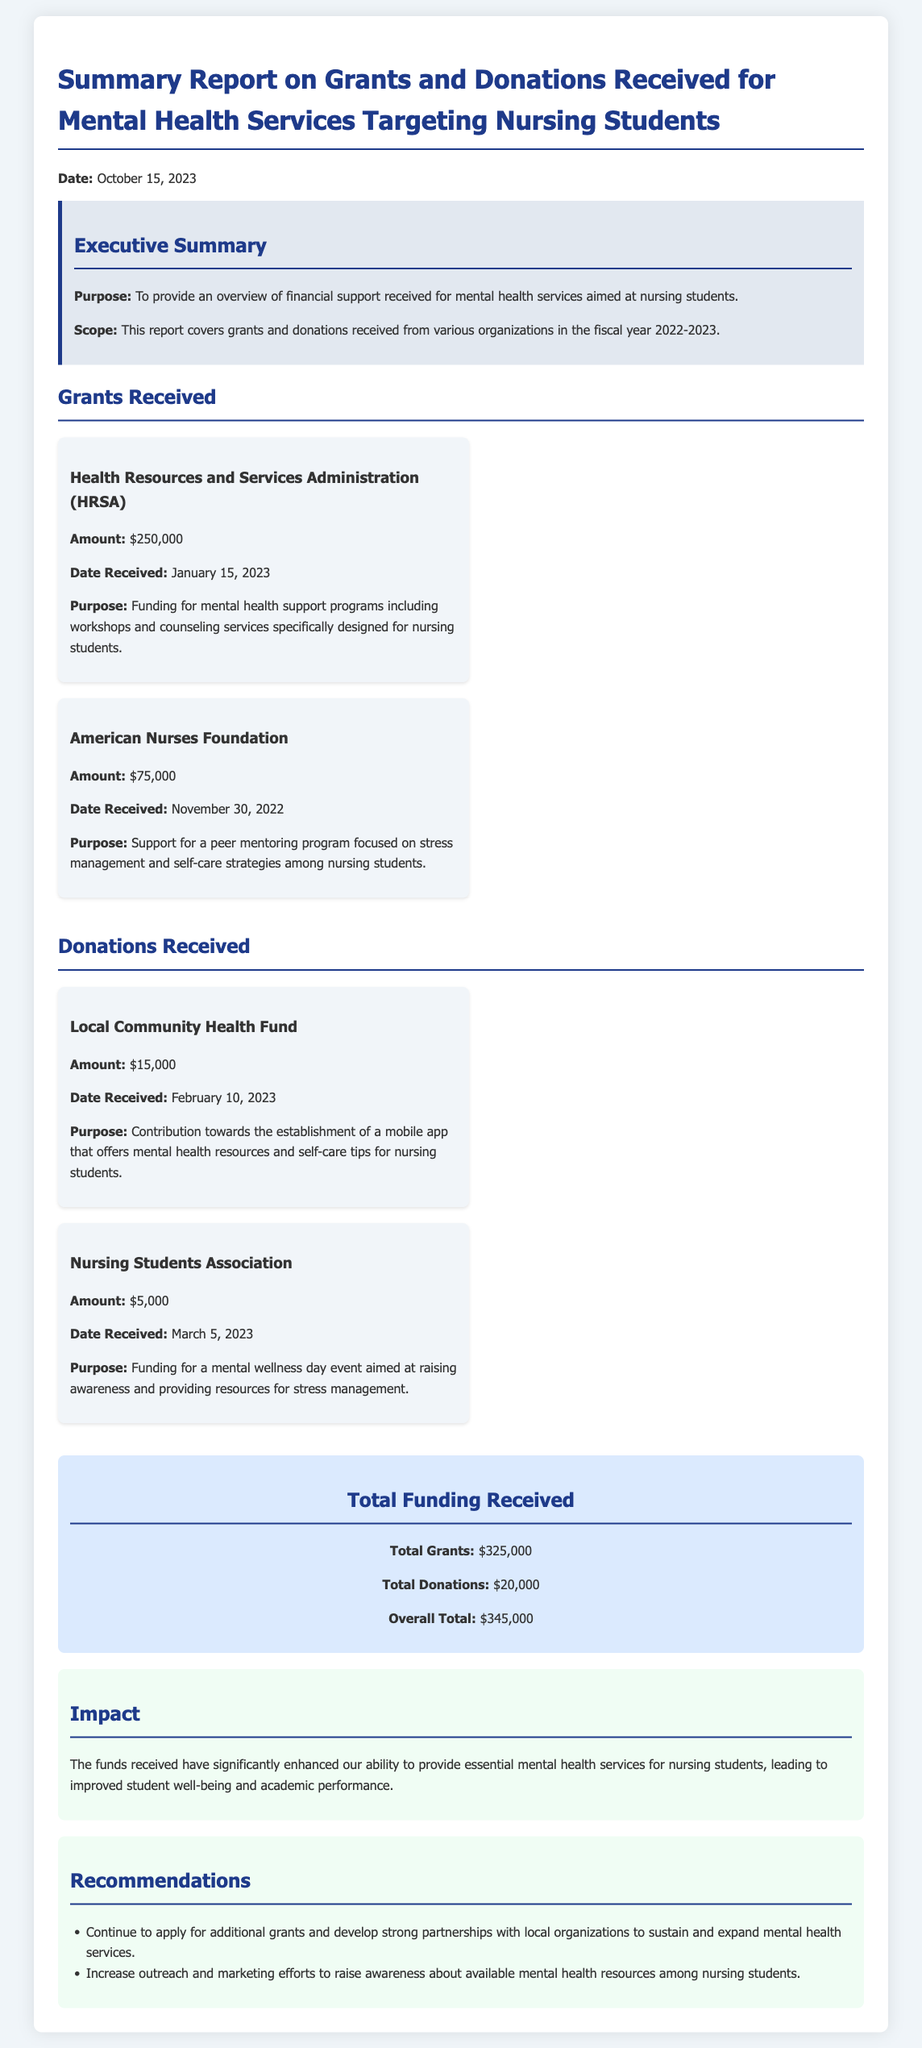what is the total grants amount? The total grants amount is listed in the document as $325,000.
Answer: $325,000 who is the recipient of the largest grant? The document states that the largest grant was received from the Health Resources and Services Administration (HRSA).
Answer: Health Resources and Services Administration (HRSA) when was the donation from the Nursing Students Association received? The document specifies that the donation was received on March 5, 2023.
Answer: March 5, 2023 what is the purpose of the funding from the American Nurses Foundation? The purpose is to support a peer mentoring program focused on stress management and self-care strategies among nursing students.
Answer: Support for a peer mentoring program focused on stress management and self-care strategies among nursing students what is the overall total funding received? The overall total funding is the sum of total grants and total donations reported, which amounts to $345,000.
Answer: $345,000 how many donations were listed in the report? The report mentions two donations received during the specified period.
Answer: Two what impact have the received funds had according to the report? The document indicates that the funds have improved student well-being and academic performance.
Answer: Improved student well-being and academic performance 